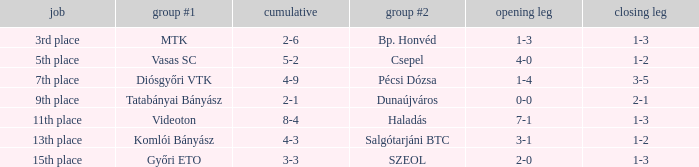Could you help me parse every detail presented in this table? {'header': ['job', 'group #1', 'cumulative', 'group #2', 'opening leg', 'closing leg'], 'rows': [['3rd place', 'MTK', '2-6', 'Bp. Honvéd', '1-3', '1-3'], ['5th place', 'Vasas SC', '5-2', 'Csepel', '4-0', '1-2'], ['7th place', 'Diósgyőri VTK', '4-9', 'Pécsi Dózsa', '1-4', '3-5'], ['9th place', 'Tatabányai Bányász', '2-1', 'Dunaújváros', '0-0', '2-1'], ['11th place', 'Videoton', '8-4', 'Haladás', '7-1', '1-3'], ['13th place', 'Komlói Bányász', '4-3', 'Salgótarjáni BTC', '3-1', '1-2'], ['15th place', 'Győri ETO', '3-3', 'SZEOL', '2-0', '1-3']]} What position has a 2-6 agg.? 3rd place. 